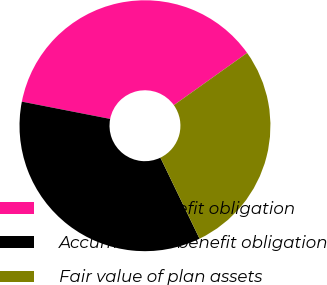Convert chart. <chart><loc_0><loc_0><loc_500><loc_500><pie_chart><fcel>Projected benefit obligation<fcel>Accumulated benefit obligation<fcel>Fair value of plan assets<nl><fcel>37.07%<fcel>35.24%<fcel>27.69%<nl></chart> 